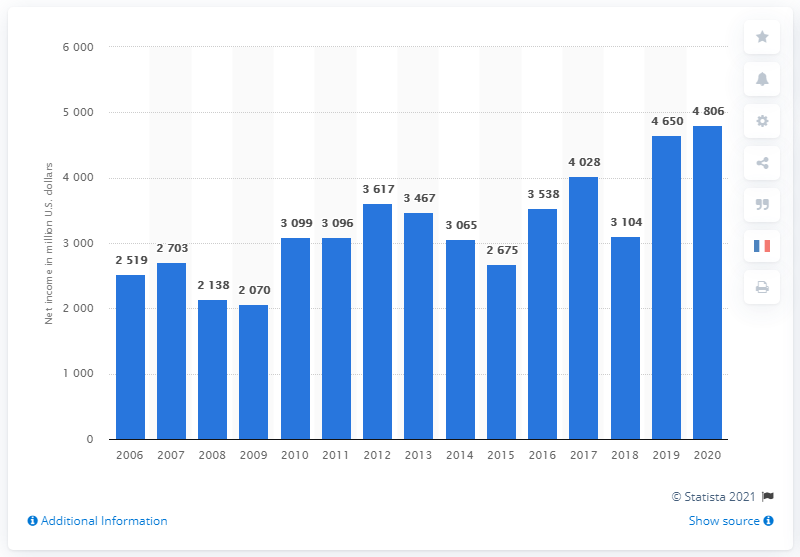Draw attention to some important aspects in this diagram. In 2020, Medtronic's net income was 4,806 million dollars. 